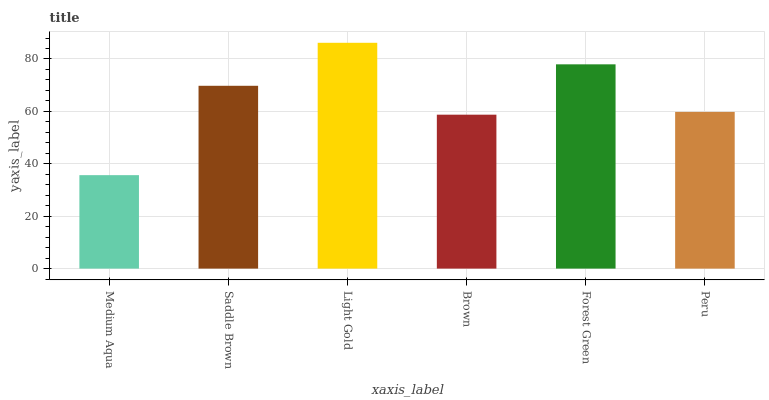Is Medium Aqua the minimum?
Answer yes or no. Yes. Is Light Gold the maximum?
Answer yes or no. Yes. Is Saddle Brown the minimum?
Answer yes or no. No. Is Saddle Brown the maximum?
Answer yes or no. No. Is Saddle Brown greater than Medium Aqua?
Answer yes or no. Yes. Is Medium Aqua less than Saddle Brown?
Answer yes or no. Yes. Is Medium Aqua greater than Saddle Brown?
Answer yes or no. No. Is Saddle Brown less than Medium Aqua?
Answer yes or no. No. Is Saddle Brown the high median?
Answer yes or no. Yes. Is Peru the low median?
Answer yes or no. Yes. Is Light Gold the high median?
Answer yes or no. No. Is Saddle Brown the low median?
Answer yes or no. No. 